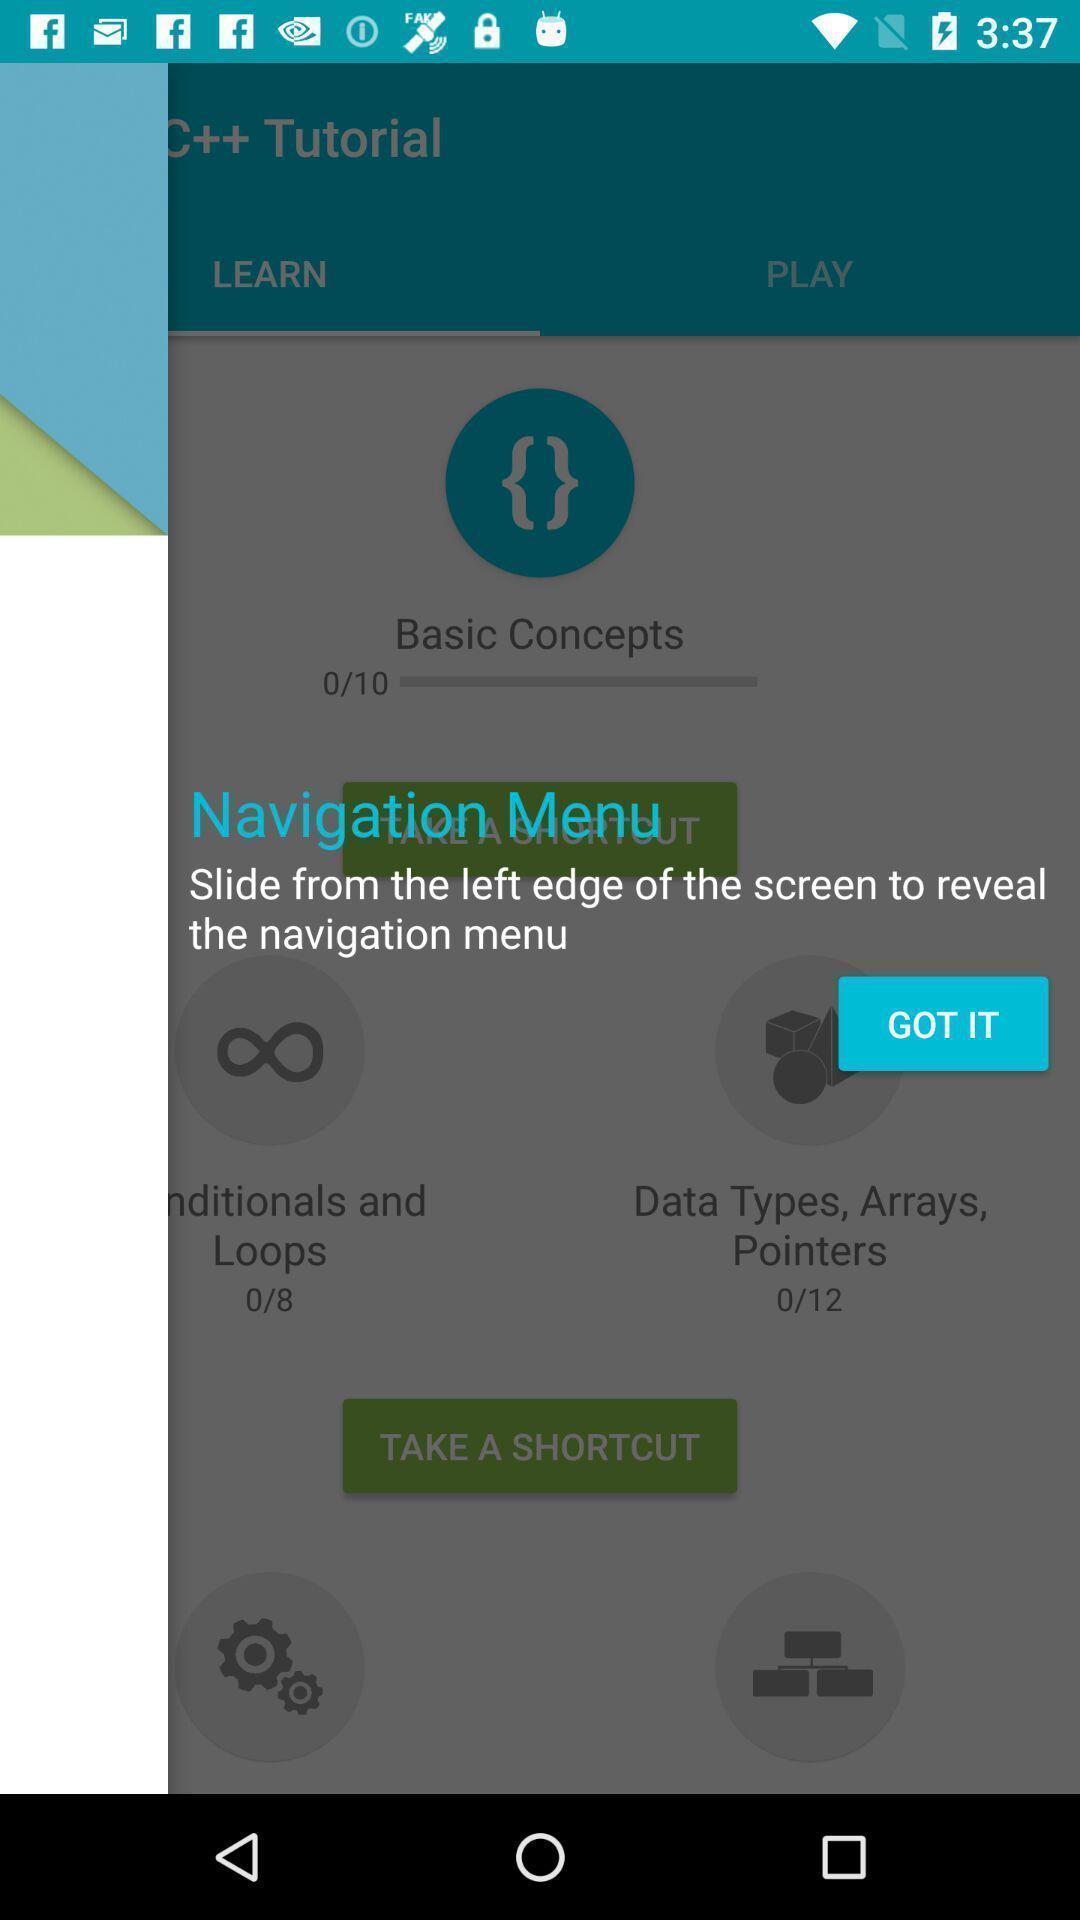Tell me about the visual elements in this screen capture. Screen displaying the notification of navigation menu. 